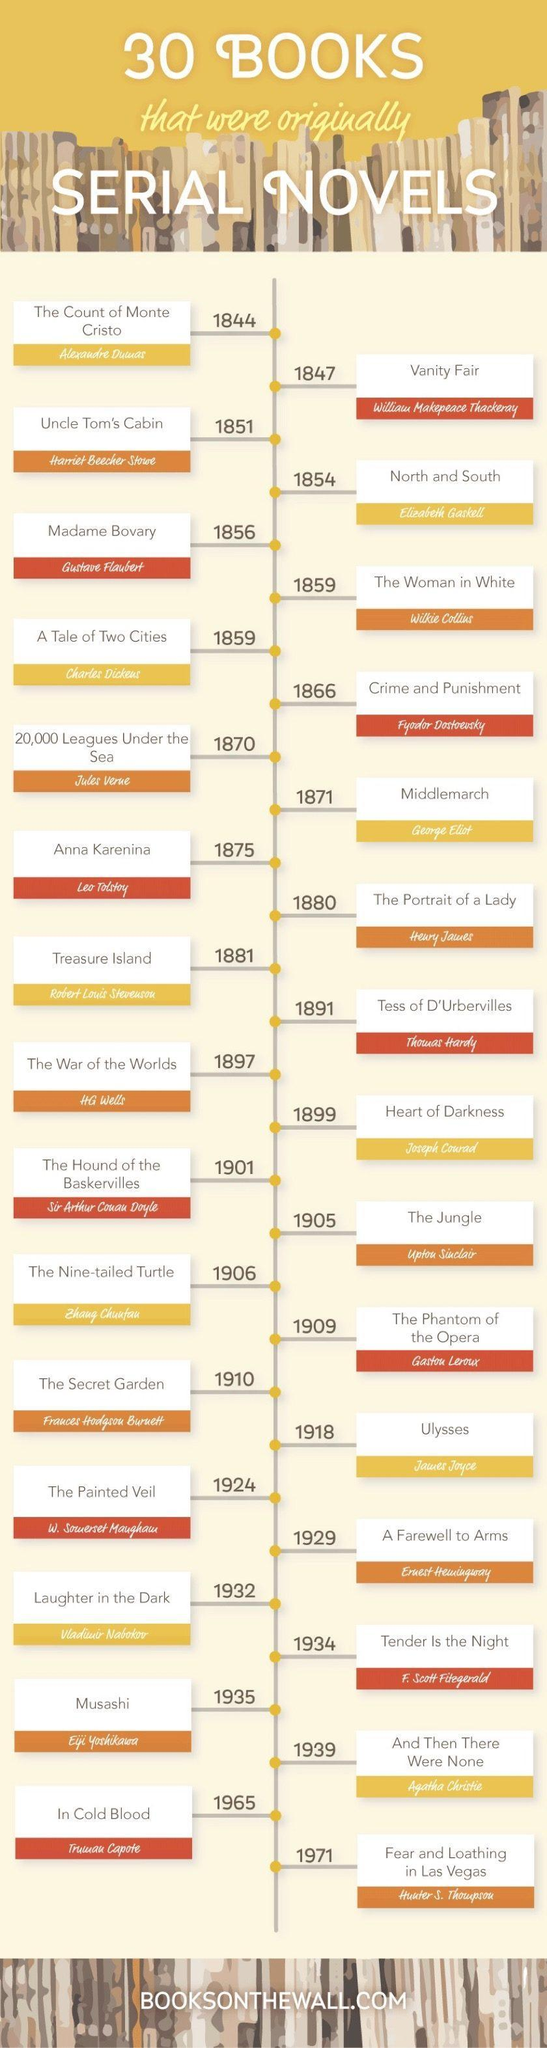Which novel wrote by Truman Capote was published in 1965?
Answer the question with a short phrase. In Cold Blood When was the novel titled 'MiddleMarch' published? 1871 Who is the author of 'The Woman in White'? Wilkie Collins When was the novel titled 'Heart of Darkness' published? 1899 Who is the author of 'The Portrait of a Lady'? Henry James 